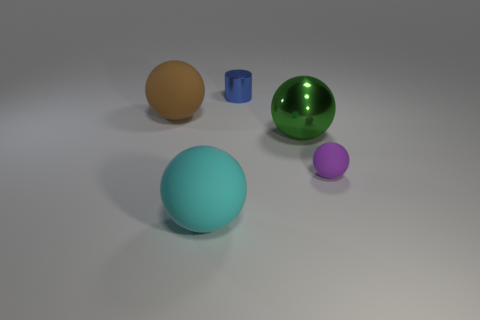Are there any other things that are the same shape as the blue metal thing?
Give a very brief answer. No. What shape is the thing that is both behind the green object and to the right of the cyan rubber sphere?
Provide a succinct answer. Cylinder. The metallic object that is behind the large brown sphere has what shape?
Keep it short and to the point. Cylinder. There is a object to the right of the large thing that is to the right of the large ball in front of the tiny sphere; what is its size?
Your answer should be very brief. Small. Do the big cyan matte object and the brown thing have the same shape?
Offer a very short reply. Yes. There is a ball that is in front of the large metal object and right of the tiny blue metallic thing; what size is it?
Your response must be concise. Small. There is a big green thing that is the same shape as the large cyan object; what is its material?
Provide a succinct answer. Metal. What material is the object right of the metallic thing in front of the blue object made of?
Your answer should be compact. Rubber. Do the big cyan thing and the metal object that is on the right side of the small blue metal cylinder have the same shape?
Your answer should be very brief. Yes. How many matte objects are big cyan spheres or big brown objects?
Provide a short and direct response. 2. 